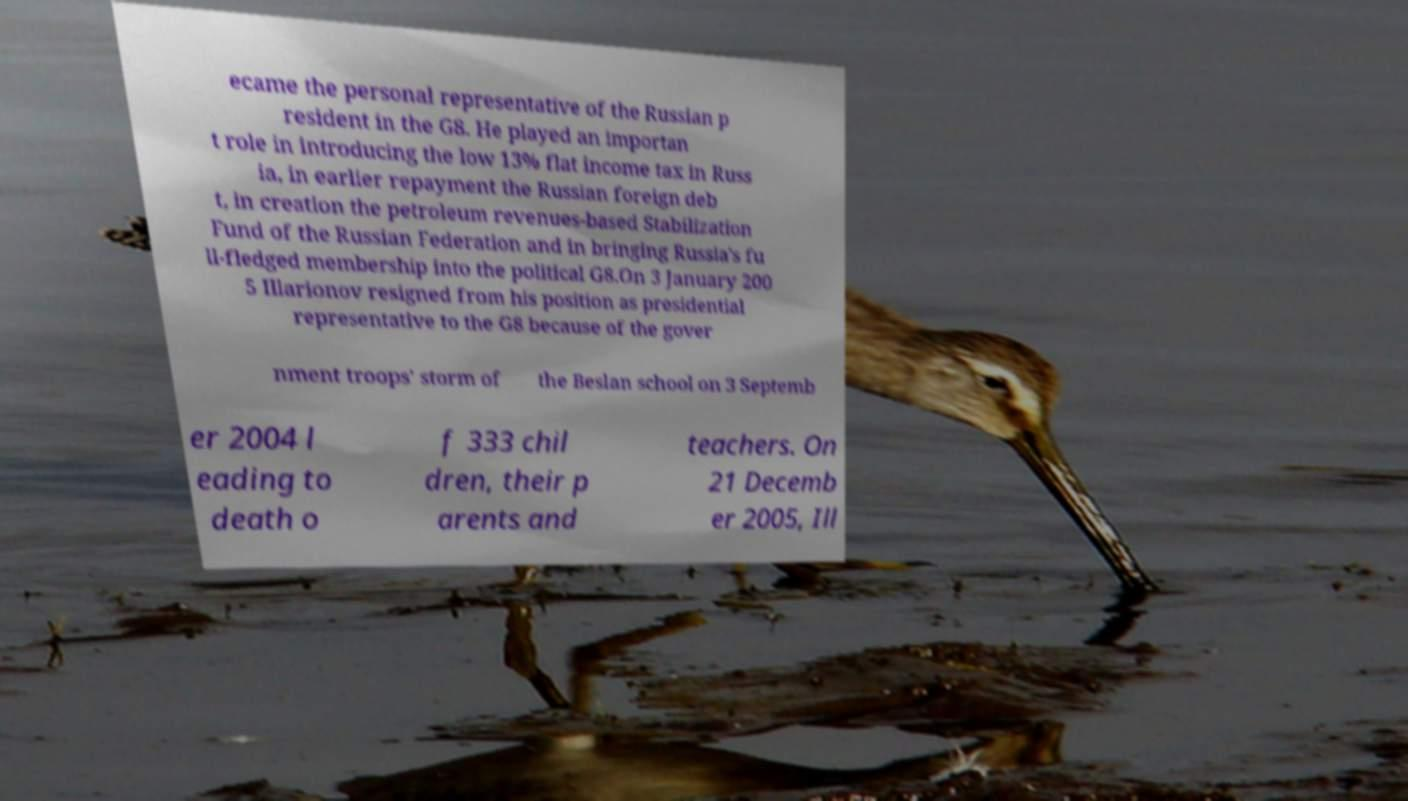Can you read and provide the text displayed in the image?This photo seems to have some interesting text. Can you extract and type it out for me? ecame the personal representative of the Russian p resident in the G8. He played an importan t role in introducing the low 13% flat income tax in Russ ia, in earlier repayment the Russian foreign deb t, in creation the petroleum revenues-based Stabilization Fund of the Russian Federation and in bringing Russia's fu ll-fledged membership into the political G8.On 3 January 200 5 Illarionov resigned from his position as presidential representative to the G8 because of the gover nment troops' storm of the Beslan school on 3 Septemb er 2004 l eading to death o f 333 chil dren, their p arents and teachers. On 21 Decemb er 2005, Ill 